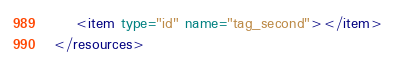<code> <loc_0><loc_0><loc_500><loc_500><_XML_>    <item type="id" name="tag_second"></item>
</resources></code> 